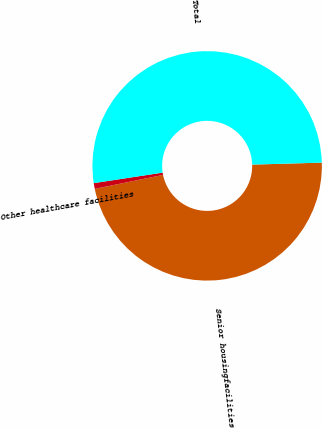<chart> <loc_0><loc_0><loc_500><loc_500><pie_chart><fcel>Senior housingfacilities<fcel>Other healthcare facilities<fcel>Total<nl><fcel>47.24%<fcel>0.81%<fcel>51.96%<nl></chart> 